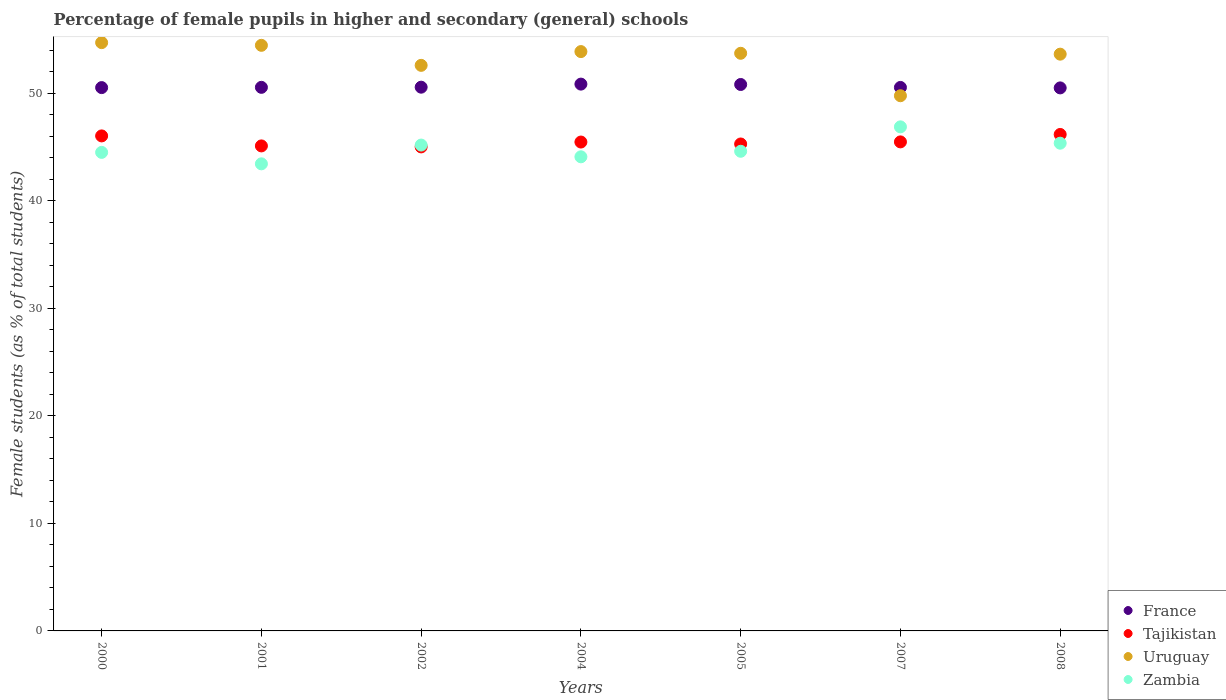How many different coloured dotlines are there?
Ensure brevity in your answer.  4. Is the number of dotlines equal to the number of legend labels?
Ensure brevity in your answer.  Yes. What is the percentage of female pupils in higher and secondary schools in France in 2000?
Your answer should be very brief. 50.54. Across all years, what is the maximum percentage of female pupils in higher and secondary schools in Zambia?
Make the answer very short. 46.89. Across all years, what is the minimum percentage of female pupils in higher and secondary schools in Zambia?
Ensure brevity in your answer.  43.45. In which year was the percentage of female pupils in higher and secondary schools in Zambia maximum?
Provide a short and direct response. 2007. In which year was the percentage of female pupils in higher and secondary schools in Zambia minimum?
Offer a very short reply. 2001. What is the total percentage of female pupils in higher and secondary schools in France in the graph?
Your response must be concise. 354.45. What is the difference between the percentage of female pupils in higher and secondary schools in Tajikistan in 2000 and that in 2007?
Ensure brevity in your answer.  0.56. What is the difference between the percentage of female pupils in higher and secondary schools in Uruguay in 2001 and the percentage of female pupils in higher and secondary schools in France in 2008?
Give a very brief answer. 3.96. What is the average percentage of female pupils in higher and secondary schools in France per year?
Keep it short and to the point. 50.64. In the year 2004, what is the difference between the percentage of female pupils in higher and secondary schools in France and percentage of female pupils in higher and secondary schools in Zambia?
Ensure brevity in your answer.  6.76. In how many years, is the percentage of female pupils in higher and secondary schools in France greater than 12 %?
Your answer should be very brief. 7. What is the ratio of the percentage of female pupils in higher and secondary schools in Tajikistan in 2001 to that in 2002?
Provide a succinct answer. 1. What is the difference between the highest and the second highest percentage of female pupils in higher and secondary schools in Tajikistan?
Make the answer very short. 0.13. What is the difference between the highest and the lowest percentage of female pupils in higher and secondary schools in Uruguay?
Your answer should be very brief. 4.94. Is the percentage of female pupils in higher and secondary schools in France strictly greater than the percentage of female pupils in higher and secondary schools in Uruguay over the years?
Your answer should be compact. No. How many dotlines are there?
Make the answer very short. 4. How many years are there in the graph?
Your answer should be compact. 7. Does the graph contain grids?
Provide a short and direct response. No. How many legend labels are there?
Offer a very short reply. 4. How are the legend labels stacked?
Provide a short and direct response. Vertical. What is the title of the graph?
Make the answer very short. Percentage of female pupils in higher and secondary (general) schools. What is the label or title of the X-axis?
Your answer should be compact. Years. What is the label or title of the Y-axis?
Your response must be concise. Female students (as % of total students). What is the Female students (as % of total students) of France in 2000?
Ensure brevity in your answer.  50.54. What is the Female students (as % of total students) of Tajikistan in 2000?
Give a very brief answer. 46.05. What is the Female students (as % of total students) of Uruguay in 2000?
Provide a succinct answer. 54.72. What is the Female students (as % of total students) of Zambia in 2000?
Your response must be concise. 44.52. What is the Female students (as % of total students) in France in 2001?
Ensure brevity in your answer.  50.57. What is the Female students (as % of total students) of Tajikistan in 2001?
Keep it short and to the point. 45.12. What is the Female students (as % of total students) of Uruguay in 2001?
Provide a succinct answer. 54.47. What is the Female students (as % of total students) of Zambia in 2001?
Your response must be concise. 43.45. What is the Female students (as % of total students) of France in 2002?
Provide a succinct answer. 50.58. What is the Female students (as % of total students) of Tajikistan in 2002?
Provide a short and direct response. 45.03. What is the Female students (as % of total students) in Uruguay in 2002?
Keep it short and to the point. 52.61. What is the Female students (as % of total students) in Zambia in 2002?
Provide a succinct answer. 45.19. What is the Female students (as % of total students) of France in 2004?
Provide a short and direct response. 50.87. What is the Female students (as % of total students) in Tajikistan in 2004?
Provide a short and direct response. 45.48. What is the Female students (as % of total students) in Uruguay in 2004?
Give a very brief answer. 53.89. What is the Female students (as % of total students) of Zambia in 2004?
Keep it short and to the point. 44.1. What is the Female students (as % of total students) in France in 2005?
Your response must be concise. 50.83. What is the Female students (as % of total students) of Tajikistan in 2005?
Make the answer very short. 45.3. What is the Female students (as % of total students) of Uruguay in 2005?
Offer a terse response. 53.73. What is the Female students (as % of total students) of Zambia in 2005?
Your answer should be compact. 44.62. What is the Female students (as % of total students) in France in 2007?
Keep it short and to the point. 50.56. What is the Female students (as % of total students) in Tajikistan in 2007?
Your response must be concise. 45.49. What is the Female students (as % of total students) in Uruguay in 2007?
Ensure brevity in your answer.  49.78. What is the Female students (as % of total students) in Zambia in 2007?
Your answer should be compact. 46.89. What is the Female students (as % of total students) in France in 2008?
Give a very brief answer. 50.51. What is the Female students (as % of total students) in Tajikistan in 2008?
Keep it short and to the point. 46.18. What is the Female students (as % of total students) in Uruguay in 2008?
Your answer should be compact. 53.65. What is the Female students (as % of total students) of Zambia in 2008?
Offer a terse response. 45.37. Across all years, what is the maximum Female students (as % of total students) in France?
Your response must be concise. 50.87. Across all years, what is the maximum Female students (as % of total students) of Tajikistan?
Provide a short and direct response. 46.18. Across all years, what is the maximum Female students (as % of total students) of Uruguay?
Make the answer very short. 54.72. Across all years, what is the maximum Female students (as % of total students) of Zambia?
Ensure brevity in your answer.  46.89. Across all years, what is the minimum Female students (as % of total students) of France?
Give a very brief answer. 50.51. Across all years, what is the minimum Female students (as % of total students) of Tajikistan?
Offer a terse response. 45.03. Across all years, what is the minimum Female students (as % of total students) in Uruguay?
Ensure brevity in your answer.  49.78. Across all years, what is the minimum Female students (as % of total students) of Zambia?
Offer a very short reply. 43.45. What is the total Female students (as % of total students) in France in the graph?
Ensure brevity in your answer.  354.45. What is the total Female students (as % of total students) of Tajikistan in the graph?
Give a very brief answer. 318.63. What is the total Female students (as % of total students) in Uruguay in the graph?
Ensure brevity in your answer.  372.87. What is the total Female students (as % of total students) in Zambia in the graph?
Your answer should be compact. 314.14. What is the difference between the Female students (as % of total students) of France in 2000 and that in 2001?
Provide a short and direct response. -0.02. What is the difference between the Female students (as % of total students) of Tajikistan in 2000 and that in 2001?
Keep it short and to the point. 0.93. What is the difference between the Female students (as % of total students) of Uruguay in 2000 and that in 2001?
Provide a short and direct response. 0.25. What is the difference between the Female students (as % of total students) of Zambia in 2000 and that in 2001?
Keep it short and to the point. 1.07. What is the difference between the Female students (as % of total students) in France in 2000 and that in 2002?
Make the answer very short. -0.04. What is the difference between the Female students (as % of total students) of Tajikistan in 2000 and that in 2002?
Your response must be concise. 1.02. What is the difference between the Female students (as % of total students) of Uruguay in 2000 and that in 2002?
Ensure brevity in your answer.  2.11. What is the difference between the Female students (as % of total students) of Zambia in 2000 and that in 2002?
Provide a short and direct response. -0.68. What is the difference between the Female students (as % of total students) of France in 2000 and that in 2004?
Provide a short and direct response. -0.32. What is the difference between the Female students (as % of total students) in Tajikistan in 2000 and that in 2004?
Your answer should be compact. 0.57. What is the difference between the Female students (as % of total students) in Uruguay in 2000 and that in 2004?
Provide a short and direct response. 0.83. What is the difference between the Female students (as % of total students) in Zambia in 2000 and that in 2004?
Your answer should be compact. 0.41. What is the difference between the Female students (as % of total students) of France in 2000 and that in 2005?
Your answer should be compact. -0.29. What is the difference between the Female students (as % of total students) of Tajikistan in 2000 and that in 2005?
Your response must be concise. 0.75. What is the difference between the Female students (as % of total students) in Uruguay in 2000 and that in 2005?
Make the answer very short. 0.99. What is the difference between the Female students (as % of total students) of Zambia in 2000 and that in 2005?
Offer a terse response. -0.1. What is the difference between the Female students (as % of total students) in France in 2000 and that in 2007?
Give a very brief answer. -0.02. What is the difference between the Female students (as % of total students) in Tajikistan in 2000 and that in 2007?
Your answer should be compact. 0.56. What is the difference between the Female students (as % of total students) in Uruguay in 2000 and that in 2007?
Your response must be concise. 4.94. What is the difference between the Female students (as % of total students) in Zambia in 2000 and that in 2007?
Offer a very short reply. -2.37. What is the difference between the Female students (as % of total students) of France in 2000 and that in 2008?
Your answer should be compact. 0.03. What is the difference between the Female students (as % of total students) in Tajikistan in 2000 and that in 2008?
Provide a short and direct response. -0.13. What is the difference between the Female students (as % of total students) in Uruguay in 2000 and that in 2008?
Provide a succinct answer. 1.07. What is the difference between the Female students (as % of total students) in Zambia in 2000 and that in 2008?
Ensure brevity in your answer.  -0.85. What is the difference between the Female students (as % of total students) of France in 2001 and that in 2002?
Make the answer very short. -0.01. What is the difference between the Female students (as % of total students) in Tajikistan in 2001 and that in 2002?
Your response must be concise. 0.09. What is the difference between the Female students (as % of total students) of Uruguay in 2001 and that in 2002?
Provide a short and direct response. 1.86. What is the difference between the Female students (as % of total students) of Zambia in 2001 and that in 2002?
Your response must be concise. -1.75. What is the difference between the Female students (as % of total students) in France in 2001 and that in 2004?
Ensure brevity in your answer.  -0.3. What is the difference between the Female students (as % of total students) of Tajikistan in 2001 and that in 2004?
Provide a succinct answer. -0.36. What is the difference between the Female students (as % of total students) in Uruguay in 2001 and that in 2004?
Offer a terse response. 0.58. What is the difference between the Female students (as % of total students) of Zambia in 2001 and that in 2004?
Provide a succinct answer. -0.65. What is the difference between the Female students (as % of total students) in France in 2001 and that in 2005?
Give a very brief answer. -0.27. What is the difference between the Female students (as % of total students) of Tajikistan in 2001 and that in 2005?
Offer a terse response. -0.18. What is the difference between the Female students (as % of total students) in Uruguay in 2001 and that in 2005?
Offer a very short reply. 0.74. What is the difference between the Female students (as % of total students) in Zambia in 2001 and that in 2005?
Provide a succinct answer. -1.17. What is the difference between the Female students (as % of total students) in France in 2001 and that in 2007?
Keep it short and to the point. 0.01. What is the difference between the Female students (as % of total students) in Tajikistan in 2001 and that in 2007?
Offer a terse response. -0.37. What is the difference between the Female students (as % of total students) of Uruguay in 2001 and that in 2007?
Provide a short and direct response. 4.69. What is the difference between the Female students (as % of total students) of Zambia in 2001 and that in 2007?
Offer a very short reply. -3.44. What is the difference between the Female students (as % of total students) of France in 2001 and that in 2008?
Your response must be concise. 0.05. What is the difference between the Female students (as % of total students) of Tajikistan in 2001 and that in 2008?
Provide a short and direct response. -1.06. What is the difference between the Female students (as % of total students) of Uruguay in 2001 and that in 2008?
Your response must be concise. 0.82. What is the difference between the Female students (as % of total students) in Zambia in 2001 and that in 2008?
Offer a terse response. -1.92. What is the difference between the Female students (as % of total students) in France in 2002 and that in 2004?
Your answer should be compact. -0.29. What is the difference between the Female students (as % of total students) in Tajikistan in 2002 and that in 2004?
Provide a short and direct response. -0.45. What is the difference between the Female students (as % of total students) in Uruguay in 2002 and that in 2004?
Provide a succinct answer. -1.28. What is the difference between the Female students (as % of total students) of Zambia in 2002 and that in 2004?
Provide a short and direct response. 1.09. What is the difference between the Female students (as % of total students) of France in 2002 and that in 2005?
Provide a short and direct response. -0.25. What is the difference between the Female students (as % of total students) of Tajikistan in 2002 and that in 2005?
Offer a very short reply. -0.27. What is the difference between the Female students (as % of total students) of Uruguay in 2002 and that in 2005?
Your answer should be very brief. -1.12. What is the difference between the Female students (as % of total students) in Zambia in 2002 and that in 2005?
Keep it short and to the point. 0.58. What is the difference between the Female students (as % of total students) of France in 2002 and that in 2007?
Your answer should be compact. 0.02. What is the difference between the Female students (as % of total students) in Tajikistan in 2002 and that in 2007?
Offer a very short reply. -0.47. What is the difference between the Female students (as % of total students) of Uruguay in 2002 and that in 2007?
Your answer should be compact. 2.83. What is the difference between the Female students (as % of total students) of Zambia in 2002 and that in 2007?
Make the answer very short. -1.69. What is the difference between the Female students (as % of total students) in France in 2002 and that in 2008?
Your answer should be very brief. 0.07. What is the difference between the Female students (as % of total students) in Tajikistan in 2002 and that in 2008?
Offer a very short reply. -1.16. What is the difference between the Female students (as % of total students) in Uruguay in 2002 and that in 2008?
Your answer should be very brief. -1.04. What is the difference between the Female students (as % of total students) of Zambia in 2002 and that in 2008?
Your answer should be compact. -0.17. What is the difference between the Female students (as % of total students) of France in 2004 and that in 2005?
Offer a terse response. 0.04. What is the difference between the Female students (as % of total students) in Tajikistan in 2004 and that in 2005?
Your answer should be very brief. 0.18. What is the difference between the Female students (as % of total students) of Uruguay in 2004 and that in 2005?
Provide a succinct answer. 0.16. What is the difference between the Female students (as % of total students) of Zambia in 2004 and that in 2005?
Your answer should be compact. -0.51. What is the difference between the Female students (as % of total students) in France in 2004 and that in 2007?
Offer a terse response. 0.31. What is the difference between the Female students (as % of total students) of Tajikistan in 2004 and that in 2007?
Give a very brief answer. -0.01. What is the difference between the Female students (as % of total students) in Uruguay in 2004 and that in 2007?
Give a very brief answer. 4.11. What is the difference between the Female students (as % of total students) of Zambia in 2004 and that in 2007?
Give a very brief answer. -2.79. What is the difference between the Female students (as % of total students) in France in 2004 and that in 2008?
Provide a succinct answer. 0.35. What is the difference between the Female students (as % of total students) of Tajikistan in 2004 and that in 2008?
Your answer should be compact. -0.7. What is the difference between the Female students (as % of total students) in Uruguay in 2004 and that in 2008?
Provide a short and direct response. 0.24. What is the difference between the Female students (as % of total students) of Zambia in 2004 and that in 2008?
Offer a very short reply. -1.27. What is the difference between the Female students (as % of total students) in France in 2005 and that in 2007?
Provide a succinct answer. 0.27. What is the difference between the Female students (as % of total students) of Tajikistan in 2005 and that in 2007?
Ensure brevity in your answer.  -0.19. What is the difference between the Female students (as % of total students) of Uruguay in 2005 and that in 2007?
Offer a terse response. 3.95. What is the difference between the Female students (as % of total students) in Zambia in 2005 and that in 2007?
Your response must be concise. -2.27. What is the difference between the Female students (as % of total students) of France in 2005 and that in 2008?
Make the answer very short. 0.32. What is the difference between the Female students (as % of total students) of Tajikistan in 2005 and that in 2008?
Ensure brevity in your answer.  -0.89. What is the difference between the Female students (as % of total students) of Uruguay in 2005 and that in 2008?
Ensure brevity in your answer.  0.08. What is the difference between the Female students (as % of total students) in Zambia in 2005 and that in 2008?
Offer a terse response. -0.75. What is the difference between the Female students (as % of total students) in France in 2007 and that in 2008?
Your answer should be compact. 0.04. What is the difference between the Female students (as % of total students) in Tajikistan in 2007 and that in 2008?
Your response must be concise. -0.69. What is the difference between the Female students (as % of total students) in Uruguay in 2007 and that in 2008?
Keep it short and to the point. -3.87. What is the difference between the Female students (as % of total students) of Zambia in 2007 and that in 2008?
Give a very brief answer. 1.52. What is the difference between the Female students (as % of total students) in France in 2000 and the Female students (as % of total students) in Tajikistan in 2001?
Offer a very short reply. 5.42. What is the difference between the Female students (as % of total students) of France in 2000 and the Female students (as % of total students) of Uruguay in 2001?
Your answer should be compact. -3.93. What is the difference between the Female students (as % of total students) in France in 2000 and the Female students (as % of total students) in Zambia in 2001?
Give a very brief answer. 7.09. What is the difference between the Female students (as % of total students) of Tajikistan in 2000 and the Female students (as % of total students) of Uruguay in 2001?
Give a very brief answer. -8.43. What is the difference between the Female students (as % of total students) of Tajikistan in 2000 and the Female students (as % of total students) of Zambia in 2001?
Keep it short and to the point. 2.6. What is the difference between the Female students (as % of total students) in Uruguay in 2000 and the Female students (as % of total students) in Zambia in 2001?
Provide a succinct answer. 11.27. What is the difference between the Female students (as % of total students) in France in 2000 and the Female students (as % of total students) in Tajikistan in 2002?
Your answer should be very brief. 5.52. What is the difference between the Female students (as % of total students) in France in 2000 and the Female students (as % of total students) in Uruguay in 2002?
Provide a short and direct response. -2.07. What is the difference between the Female students (as % of total students) in France in 2000 and the Female students (as % of total students) in Zambia in 2002?
Provide a short and direct response. 5.35. What is the difference between the Female students (as % of total students) of Tajikistan in 2000 and the Female students (as % of total students) of Uruguay in 2002?
Offer a very short reply. -6.56. What is the difference between the Female students (as % of total students) of Tajikistan in 2000 and the Female students (as % of total students) of Zambia in 2002?
Ensure brevity in your answer.  0.85. What is the difference between the Female students (as % of total students) in Uruguay in 2000 and the Female students (as % of total students) in Zambia in 2002?
Ensure brevity in your answer.  9.53. What is the difference between the Female students (as % of total students) of France in 2000 and the Female students (as % of total students) of Tajikistan in 2004?
Your response must be concise. 5.06. What is the difference between the Female students (as % of total students) of France in 2000 and the Female students (as % of total students) of Uruguay in 2004?
Provide a short and direct response. -3.35. What is the difference between the Female students (as % of total students) of France in 2000 and the Female students (as % of total students) of Zambia in 2004?
Offer a very short reply. 6.44. What is the difference between the Female students (as % of total students) in Tajikistan in 2000 and the Female students (as % of total students) in Uruguay in 2004?
Provide a succinct answer. -7.84. What is the difference between the Female students (as % of total students) in Tajikistan in 2000 and the Female students (as % of total students) in Zambia in 2004?
Provide a short and direct response. 1.94. What is the difference between the Female students (as % of total students) in Uruguay in 2000 and the Female students (as % of total students) in Zambia in 2004?
Your response must be concise. 10.62. What is the difference between the Female students (as % of total students) of France in 2000 and the Female students (as % of total students) of Tajikistan in 2005?
Make the answer very short. 5.24. What is the difference between the Female students (as % of total students) in France in 2000 and the Female students (as % of total students) in Uruguay in 2005?
Ensure brevity in your answer.  -3.19. What is the difference between the Female students (as % of total students) of France in 2000 and the Female students (as % of total students) of Zambia in 2005?
Keep it short and to the point. 5.92. What is the difference between the Female students (as % of total students) in Tajikistan in 2000 and the Female students (as % of total students) in Uruguay in 2005?
Offer a terse response. -7.69. What is the difference between the Female students (as % of total students) of Tajikistan in 2000 and the Female students (as % of total students) of Zambia in 2005?
Keep it short and to the point. 1.43. What is the difference between the Female students (as % of total students) in Uruguay in 2000 and the Female students (as % of total students) in Zambia in 2005?
Ensure brevity in your answer.  10.11. What is the difference between the Female students (as % of total students) of France in 2000 and the Female students (as % of total students) of Tajikistan in 2007?
Offer a terse response. 5.05. What is the difference between the Female students (as % of total students) of France in 2000 and the Female students (as % of total students) of Uruguay in 2007?
Your answer should be very brief. 0.76. What is the difference between the Female students (as % of total students) of France in 2000 and the Female students (as % of total students) of Zambia in 2007?
Make the answer very short. 3.65. What is the difference between the Female students (as % of total students) of Tajikistan in 2000 and the Female students (as % of total students) of Uruguay in 2007?
Your response must be concise. -3.74. What is the difference between the Female students (as % of total students) of Tajikistan in 2000 and the Female students (as % of total students) of Zambia in 2007?
Keep it short and to the point. -0.84. What is the difference between the Female students (as % of total students) of Uruguay in 2000 and the Female students (as % of total students) of Zambia in 2007?
Provide a short and direct response. 7.83. What is the difference between the Female students (as % of total students) of France in 2000 and the Female students (as % of total students) of Tajikistan in 2008?
Provide a short and direct response. 4.36. What is the difference between the Female students (as % of total students) in France in 2000 and the Female students (as % of total students) in Uruguay in 2008?
Ensure brevity in your answer.  -3.11. What is the difference between the Female students (as % of total students) in France in 2000 and the Female students (as % of total students) in Zambia in 2008?
Your response must be concise. 5.17. What is the difference between the Female students (as % of total students) of Tajikistan in 2000 and the Female students (as % of total students) of Uruguay in 2008?
Your answer should be very brief. -7.6. What is the difference between the Female students (as % of total students) in Tajikistan in 2000 and the Female students (as % of total students) in Zambia in 2008?
Offer a very short reply. 0.68. What is the difference between the Female students (as % of total students) of Uruguay in 2000 and the Female students (as % of total students) of Zambia in 2008?
Ensure brevity in your answer.  9.35. What is the difference between the Female students (as % of total students) in France in 2001 and the Female students (as % of total students) in Tajikistan in 2002?
Provide a succinct answer. 5.54. What is the difference between the Female students (as % of total students) in France in 2001 and the Female students (as % of total students) in Uruguay in 2002?
Ensure brevity in your answer.  -2.05. What is the difference between the Female students (as % of total students) of France in 2001 and the Female students (as % of total students) of Zambia in 2002?
Your response must be concise. 5.37. What is the difference between the Female students (as % of total students) in Tajikistan in 2001 and the Female students (as % of total students) in Uruguay in 2002?
Make the answer very short. -7.49. What is the difference between the Female students (as % of total students) in Tajikistan in 2001 and the Female students (as % of total students) in Zambia in 2002?
Your answer should be compact. -0.08. What is the difference between the Female students (as % of total students) in Uruguay in 2001 and the Female students (as % of total students) in Zambia in 2002?
Ensure brevity in your answer.  9.28. What is the difference between the Female students (as % of total students) of France in 2001 and the Female students (as % of total students) of Tajikistan in 2004?
Provide a short and direct response. 5.09. What is the difference between the Female students (as % of total students) in France in 2001 and the Female students (as % of total students) in Uruguay in 2004?
Provide a succinct answer. -3.33. What is the difference between the Female students (as % of total students) of France in 2001 and the Female students (as % of total students) of Zambia in 2004?
Make the answer very short. 6.46. What is the difference between the Female students (as % of total students) of Tajikistan in 2001 and the Female students (as % of total students) of Uruguay in 2004?
Provide a succinct answer. -8.77. What is the difference between the Female students (as % of total students) of Tajikistan in 2001 and the Female students (as % of total students) of Zambia in 2004?
Offer a terse response. 1.01. What is the difference between the Female students (as % of total students) in Uruguay in 2001 and the Female students (as % of total students) in Zambia in 2004?
Your answer should be very brief. 10.37. What is the difference between the Female students (as % of total students) in France in 2001 and the Female students (as % of total students) in Tajikistan in 2005?
Keep it short and to the point. 5.27. What is the difference between the Female students (as % of total students) of France in 2001 and the Female students (as % of total students) of Uruguay in 2005?
Provide a succinct answer. -3.17. What is the difference between the Female students (as % of total students) of France in 2001 and the Female students (as % of total students) of Zambia in 2005?
Provide a short and direct response. 5.95. What is the difference between the Female students (as % of total students) in Tajikistan in 2001 and the Female students (as % of total students) in Uruguay in 2005?
Ensure brevity in your answer.  -8.62. What is the difference between the Female students (as % of total students) of Tajikistan in 2001 and the Female students (as % of total students) of Zambia in 2005?
Provide a succinct answer. 0.5. What is the difference between the Female students (as % of total students) of Uruguay in 2001 and the Female students (as % of total students) of Zambia in 2005?
Your answer should be very brief. 9.86. What is the difference between the Female students (as % of total students) in France in 2001 and the Female students (as % of total students) in Tajikistan in 2007?
Make the answer very short. 5.07. What is the difference between the Female students (as % of total students) in France in 2001 and the Female students (as % of total students) in Uruguay in 2007?
Offer a terse response. 0.78. What is the difference between the Female students (as % of total students) in France in 2001 and the Female students (as % of total students) in Zambia in 2007?
Your response must be concise. 3.68. What is the difference between the Female students (as % of total students) in Tajikistan in 2001 and the Female students (as % of total students) in Uruguay in 2007?
Keep it short and to the point. -4.67. What is the difference between the Female students (as % of total students) of Tajikistan in 2001 and the Female students (as % of total students) of Zambia in 2007?
Your answer should be compact. -1.77. What is the difference between the Female students (as % of total students) of Uruguay in 2001 and the Female students (as % of total students) of Zambia in 2007?
Your response must be concise. 7.58. What is the difference between the Female students (as % of total students) in France in 2001 and the Female students (as % of total students) in Tajikistan in 2008?
Your response must be concise. 4.38. What is the difference between the Female students (as % of total students) in France in 2001 and the Female students (as % of total students) in Uruguay in 2008?
Offer a very short reply. -3.09. What is the difference between the Female students (as % of total students) in France in 2001 and the Female students (as % of total students) in Zambia in 2008?
Provide a short and direct response. 5.2. What is the difference between the Female students (as % of total students) in Tajikistan in 2001 and the Female students (as % of total students) in Uruguay in 2008?
Offer a very short reply. -8.53. What is the difference between the Female students (as % of total students) in Tajikistan in 2001 and the Female students (as % of total students) in Zambia in 2008?
Keep it short and to the point. -0.25. What is the difference between the Female students (as % of total students) of Uruguay in 2001 and the Female students (as % of total students) of Zambia in 2008?
Offer a very short reply. 9.1. What is the difference between the Female students (as % of total students) in France in 2002 and the Female students (as % of total students) in Tajikistan in 2004?
Keep it short and to the point. 5.1. What is the difference between the Female students (as % of total students) in France in 2002 and the Female students (as % of total students) in Uruguay in 2004?
Make the answer very short. -3.31. What is the difference between the Female students (as % of total students) of France in 2002 and the Female students (as % of total students) of Zambia in 2004?
Ensure brevity in your answer.  6.48. What is the difference between the Female students (as % of total students) in Tajikistan in 2002 and the Female students (as % of total students) in Uruguay in 2004?
Give a very brief answer. -8.87. What is the difference between the Female students (as % of total students) in Tajikistan in 2002 and the Female students (as % of total students) in Zambia in 2004?
Provide a short and direct response. 0.92. What is the difference between the Female students (as % of total students) of Uruguay in 2002 and the Female students (as % of total students) of Zambia in 2004?
Your answer should be very brief. 8.51. What is the difference between the Female students (as % of total students) of France in 2002 and the Female students (as % of total students) of Tajikistan in 2005?
Your response must be concise. 5.28. What is the difference between the Female students (as % of total students) of France in 2002 and the Female students (as % of total students) of Uruguay in 2005?
Offer a very short reply. -3.15. What is the difference between the Female students (as % of total students) in France in 2002 and the Female students (as % of total students) in Zambia in 2005?
Your response must be concise. 5.96. What is the difference between the Female students (as % of total students) of Tajikistan in 2002 and the Female students (as % of total students) of Uruguay in 2005?
Your answer should be compact. -8.71. What is the difference between the Female students (as % of total students) of Tajikistan in 2002 and the Female students (as % of total students) of Zambia in 2005?
Give a very brief answer. 0.41. What is the difference between the Female students (as % of total students) in Uruguay in 2002 and the Female students (as % of total students) in Zambia in 2005?
Make the answer very short. 7.99. What is the difference between the Female students (as % of total students) in France in 2002 and the Female students (as % of total students) in Tajikistan in 2007?
Keep it short and to the point. 5.09. What is the difference between the Female students (as % of total students) in France in 2002 and the Female students (as % of total students) in Uruguay in 2007?
Make the answer very short. 0.8. What is the difference between the Female students (as % of total students) of France in 2002 and the Female students (as % of total students) of Zambia in 2007?
Make the answer very short. 3.69. What is the difference between the Female students (as % of total students) of Tajikistan in 2002 and the Female students (as % of total students) of Uruguay in 2007?
Your response must be concise. -4.76. What is the difference between the Female students (as % of total students) of Tajikistan in 2002 and the Female students (as % of total students) of Zambia in 2007?
Provide a short and direct response. -1.86. What is the difference between the Female students (as % of total students) in Uruguay in 2002 and the Female students (as % of total students) in Zambia in 2007?
Offer a terse response. 5.72. What is the difference between the Female students (as % of total students) in France in 2002 and the Female students (as % of total students) in Tajikistan in 2008?
Offer a terse response. 4.4. What is the difference between the Female students (as % of total students) in France in 2002 and the Female students (as % of total students) in Uruguay in 2008?
Ensure brevity in your answer.  -3.07. What is the difference between the Female students (as % of total students) of France in 2002 and the Female students (as % of total students) of Zambia in 2008?
Provide a succinct answer. 5.21. What is the difference between the Female students (as % of total students) in Tajikistan in 2002 and the Female students (as % of total students) in Uruguay in 2008?
Your response must be concise. -8.63. What is the difference between the Female students (as % of total students) in Tajikistan in 2002 and the Female students (as % of total students) in Zambia in 2008?
Your answer should be compact. -0.34. What is the difference between the Female students (as % of total students) in Uruguay in 2002 and the Female students (as % of total students) in Zambia in 2008?
Ensure brevity in your answer.  7.24. What is the difference between the Female students (as % of total students) of France in 2004 and the Female students (as % of total students) of Tajikistan in 2005?
Your answer should be compact. 5.57. What is the difference between the Female students (as % of total students) of France in 2004 and the Female students (as % of total students) of Uruguay in 2005?
Your answer should be very brief. -2.87. What is the difference between the Female students (as % of total students) of France in 2004 and the Female students (as % of total students) of Zambia in 2005?
Provide a succinct answer. 6.25. What is the difference between the Female students (as % of total students) of Tajikistan in 2004 and the Female students (as % of total students) of Uruguay in 2005?
Ensure brevity in your answer.  -8.26. What is the difference between the Female students (as % of total students) in Tajikistan in 2004 and the Female students (as % of total students) in Zambia in 2005?
Provide a short and direct response. 0.86. What is the difference between the Female students (as % of total students) in Uruguay in 2004 and the Female students (as % of total students) in Zambia in 2005?
Give a very brief answer. 9.27. What is the difference between the Female students (as % of total students) of France in 2004 and the Female students (as % of total students) of Tajikistan in 2007?
Offer a terse response. 5.37. What is the difference between the Female students (as % of total students) in France in 2004 and the Female students (as % of total students) in Uruguay in 2007?
Your response must be concise. 1.08. What is the difference between the Female students (as % of total students) of France in 2004 and the Female students (as % of total students) of Zambia in 2007?
Your answer should be compact. 3.98. What is the difference between the Female students (as % of total students) in Tajikistan in 2004 and the Female students (as % of total students) in Uruguay in 2007?
Your answer should be very brief. -4.31. What is the difference between the Female students (as % of total students) of Tajikistan in 2004 and the Female students (as % of total students) of Zambia in 2007?
Offer a terse response. -1.41. What is the difference between the Female students (as % of total students) in Uruguay in 2004 and the Female students (as % of total students) in Zambia in 2007?
Ensure brevity in your answer.  7. What is the difference between the Female students (as % of total students) in France in 2004 and the Female students (as % of total students) in Tajikistan in 2008?
Your answer should be compact. 4.68. What is the difference between the Female students (as % of total students) in France in 2004 and the Female students (as % of total students) in Uruguay in 2008?
Your answer should be compact. -2.79. What is the difference between the Female students (as % of total students) of France in 2004 and the Female students (as % of total students) of Zambia in 2008?
Ensure brevity in your answer.  5.5. What is the difference between the Female students (as % of total students) in Tajikistan in 2004 and the Female students (as % of total students) in Uruguay in 2008?
Provide a succinct answer. -8.17. What is the difference between the Female students (as % of total students) of Tajikistan in 2004 and the Female students (as % of total students) of Zambia in 2008?
Give a very brief answer. 0.11. What is the difference between the Female students (as % of total students) in Uruguay in 2004 and the Female students (as % of total students) in Zambia in 2008?
Ensure brevity in your answer.  8.52. What is the difference between the Female students (as % of total students) of France in 2005 and the Female students (as % of total students) of Tajikistan in 2007?
Keep it short and to the point. 5.34. What is the difference between the Female students (as % of total students) in France in 2005 and the Female students (as % of total students) in Uruguay in 2007?
Your response must be concise. 1.05. What is the difference between the Female students (as % of total students) in France in 2005 and the Female students (as % of total students) in Zambia in 2007?
Offer a very short reply. 3.94. What is the difference between the Female students (as % of total students) in Tajikistan in 2005 and the Female students (as % of total students) in Uruguay in 2007?
Your answer should be very brief. -4.49. What is the difference between the Female students (as % of total students) of Tajikistan in 2005 and the Female students (as % of total students) of Zambia in 2007?
Provide a succinct answer. -1.59. What is the difference between the Female students (as % of total students) of Uruguay in 2005 and the Female students (as % of total students) of Zambia in 2007?
Your response must be concise. 6.84. What is the difference between the Female students (as % of total students) of France in 2005 and the Female students (as % of total students) of Tajikistan in 2008?
Provide a short and direct response. 4.65. What is the difference between the Female students (as % of total students) of France in 2005 and the Female students (as % of total students) of Uruguay in 2008?
Give a very brief answer. -2.82. What is the difference between the Female students (as % of total students) of France in 2005 and the Female students (as % of total students) of Zambia in 2008?
Give a very brief answer. 5.46. What is the difference between the Female students (as % of total students) in Tajikistan in 2005 and the Female students (as % of total students) in Uruguay in 2008?
Provide a short and direct response. -8.36. What is the difference between the Female students (as % of total students) in Tajikistan in 2005 and the Female students (as % of total students) in Zambia in 2008?
Provide a succinct answer. -0.07. What is the difference between the Female students (as % of total students) in Uruguay in 2005 and the Female students (as % of total students) in Zambia in 2008?
Your answer should be very brief. 8.36. What is the difference between the Female students (as % of total students) in France in 2007 and the Female students (as % of total students) in Tajikistan in 2008?
Keep it short and to the point. 4.38. What is the difference between the Female students (as % of total students) of France in 2007 and the Female students (as % of total students) of Uruguay in 2008?
Your answer should be compact. -3.09. What is the difference between the Female students (as % of total students) in France in 2007 and the Female students (as % of total students) in Zambia in 2008?
Ensure brevity in your answer.  5.19. What is the difference between the Female students (as % of total students) of Tajikistan in 2007 and the Female students (as % of total students) of Uruguay in 2008?
Offer a very short reply. -8.16. What is the difference between the Female students (as % of total students) of Tajikistan in 2007 and the Female students (as % of total students) of Zambia in 2008?
Your answer should be very brief. 0.12. What is the difference between the Female students (as % of total students) in Uruguay in 2007 and the Female students (as % of total students) in Zambia in 2008?
Keep it short and to the point. 4.41. What is the average Female students (as % of total students) of France per year?
Your answer should be very brief. 50.64. What is the average Female students (as % of total students) of Tajikistan per year?
Offer a terse response. 45.52. What is the average Female students (as % of total students) of Uruguay per year?
Keep it short and to the point. 53.27. What is the average Female students (as % of total students) in Zambia per year?
Your answer should be compact. 44.88. In the year 2000, what is the difference between the Female students (as % of total students) of France and Female students (as % of total students) of Tajikistan?
Keep it short and to the point. 4.49. In the year 2000, what is the difference between the Female students (as % of total students) in France and Female students (as % of total students) in Uruguay?
Your response must be concise. -4.18. In the year 2000, what is the difference between the Female students (as % of total students) of France and Female students (as % of total students) of Zambia?
Provide a succinct answer. 6.03. In the year 2000, what is the difference between the Female students (as % of total students) of Tajikistan and Female students (as % of total students) of Uruguay?
Offer a terse response. -8.68. In the year 2000, what is the difference between the Female students (as % of total students) in Tajikistan and Female students (as % of total students) in Zambia?
Your answer should be compact. 1.53. In the year 2000, what is the difference between the Female students (as % of total students) in Uruguay and Female students (as % of total students) in Zambia?
Offer a very short reply. 10.21. In the year 2001, what is the difference between the Female students (as % of total students) in France and Female students (as % of total students) in Tajikistan?
Provide a short and direct response. 5.45. In the year 2001, what is the difference between the Female students (as % of total students) in France and Female students (as % of total students) in Uruguay?
Your answer should be compact. -3.91. In the year 2001, what is the difference between the Female students (as % of total students) of France and Female students (as % of total students) of Zambia?
Make the answer very short. 7.12. In the year 2001, what is the difference between the Female students (as % of total students) of Tajikistan and Female students (as % of total students) of Uruguay?
Provide a short and direct response. -9.36. In the year 2001, what is the difference between the Female students (as % of total students) in Tajikistan and Female students (as % of total students) in Zambia?
Give a very brief answer. 1.67. In the year 2001, what is the difference between the Female students (as % of total students) of Uruguay and Female students (as % of total students) of Zambia?
Your answer should be compact. 11.02. In the year 2002, what is the difference between the Female students (as % of total students) of France and Female students (as % of total students) of Tajikistan?
Offer a very short reply. 5.55. In the year 2002, what is the difference between the Female students (as % of total students) in France and Female students (as % of total students) in Uruguay?
Ensure brevity in your answer.  -2.03. In the year 2002, what is the difference between the Female students (as % of total students) of France and Female students (as % of total students) of Zambia?
Keep it short and to the point. 5.38. In the year 2002, what is the difference between the Female students (as % of total students) in Tajikistan and Female students (as % of total students) in Uruguay?
Make the answer very short. -7.59. In the year 2002, what is the difference between the Female students (as % of total students) in Tajikistan and Female students (as % of total students) in Zambia?
Ensure brevity in your answer.  -0.17. In the year 2002, what is the difference between the Female students (as % of total students) in Uruguay and Female students (as % of total students) in Zambia?
Offer a very short reply. 7.42. In the year 2004, what is the difference between the Female students (as % of total students) of France and Female students (as % of total students) of Tajikistan?
Offer a terse response. 5.39. In the year 2004, what is the difference between the Female students (as % of total students) in France and Female students (as % of total students) in Uruguay?
Provide a succinct answer. -3.03. In the year 2004, what is the difference between the Female students (as % of total students) of France and Female students (as % of total students) of Zambia?
Your answer should be compact. 6.76. In the year 2004, what is the difference between the Female students (as % of total students) in Tajikistan and Female students (as % of total students) in Uruguay?
Provide a succinct answer. -8.41. In the year 2004, what is the difference between the Female students (as % of total students) of Tajikistan and Female students (as % of total students) of Zambia?
Provide a succinct answer. 1.37. In the year 2004, what is the difference between the Female students (as % of total students) of Uruguay and Female students (as % of total students) of Zambia?
Offer a terse response. 9.79. In the year 2005, what is the difference between the Female students (as % of total students) of France and Female students (as % of total students) of Tajikistan?
Your answer should be compact. 5.53. In the year 2005, what is the difference between the Female students (as % of total students) of France and Female students (as % of total students) of Uruguay?
Give a very brief answer. -2.9. In the year 2005, what is the difference between the Female students (as % of total students) of France and Female students (as % of total students) of Zambia?
Offer a terse response. 6.21. In the year 2005, what is the difference between the Female students (as % of total students) in Tajikistan and Female students (as % of total students) in Uruguay?
Offer a terse response. -8.44. In the year 2005, what is the difference between the Female students (as % of total students) in Tajikistan and Female students (as % of total students) in Zambia?
Provide a succinct answer. 0.68. In the year 2005, what is the difference between the Female students (as % of total students) in Uruguay and Female students (as % of total students) in Zambia?
Offer a very short reply. 9.12. In the year 2007, what is the difference between the Female students (as % of total students) in France and Female students (as % of total students) in Tajikistan?
Provide a succinct answer. 5.07. In the year 2007, what is the difference between the Female students (as % of total students) of France and Female students (as % of total students) of Uruguay?
Provide a succinct answer. 0.77. In the year 2007, what is the difference between the Female students (as % of total students) of France and Female students (as % of total students) of Zambia?
Your answer should be very brief. 3.67. In the year 2007, what is the difference between the Female students (as % of total students) in Tajikistan and Female students (as % of total students) in Uruguay?
Provide a succinct answer. -4.29. In the year 2007, what is the difference between the Female students (as % of total students) of Tajikistan and Female students (as % of total students) of Zambia?
Your answer should be very brief. -1.4. In the year 2007, what is the difference between the Female students (as % of total students) in Uruguay and Female students (as % of total students) in Zambia?
Make the answer very short. 2.9. In the year 2008, what is the difference between the Female students (as % of total students) of France and Female students (as % of total students) of Tajikistan?
Your answer should be very brief. 4.33. In the year 2008, what is the difference between the Female students (as % of total students) in France and Female students (as % of total students) in Uruguay?
Offer a very short reply. -3.14. In the year 2008, what is the difference between the Female students (as % of total students) in France and Female students (as % of total students) in Zambia?
Provide a succinct answer. 5.14. In the year 2008, what is the difference between the Female students (as % of total students) of Tajikistan and Female students (as % of total students) of Uruguay?
Ensure brevity in your answer.  -7.47. In the year 2008, what is the difference between the Female students (as % of total students) in Tajikistan and Female students (as % of total students) in Zambia?
Your answer should be compact. 0.81. In the year 2008, what is the difference between the Female students (as % of total students) of Uruguay and Female students (as % of total students) of Zambia?
Your answer should be compact. 8.28. What is the ratio of the Female students (as % of total students) in Tajikistan in 2000 to that in 2001?
Provide a succinct answer. 1.02. What is the ratio of the Female students (as % of total students) of Zambia in 2000 to that in 2001?
Your answer should be compact. 1.02. What is the ratio of the Female students (as % of total students) of Tajikistan in 2000 to that in 2002?
Your answer should be compact. 1.02. What is the ratio of the Female students (as % of total students) of Uruguay in 2000 to that in 2002?
Offer a terse response. 1.04. What is the ratio of the Female students (as % of total students) in Zambia in 2000 to that in 2002?
Ensure brevity in your answer.  0.98. What is the ratio of the Female students (as % of total students) in France in 2000 to that in 2004?
Provide a succinct answer. 0.99. What is the ratio of the Female students (as % of total students) in Tajikistan in 2000 to that in 2004?
Keep it short and to the point. 1.01. What is the ratio of the Female students (as % of total students) in Uruguay in 2000 to that in 2004?
Offer a very short reply. 1.02. What is the ratio of the Female students (as % of total students) in Zambia in 2000 to that in 2004?
Make the answer very short. 1.01. What is the ratio of the Female students (as % of total students) in France in 2000 to that in 2005?
Provide a succinct answer. 0.99. What is the ratio of the Female students (as % of total students) in Tajikistan in 2000 to that in 2005?
Offer a very short reply. 1.02. What is the ratio of the Female students (as % of total students) of Uruguay in 2000 to that in 2005?
Make the answer very short. 1.02. What is the ratio of the Female students (as % of total students) of Zambia in 2000 to that in 2005?
Keep it short and to the point. 1. What is the ratio of the Female students (as % of total students) of Tajikistan in 2000 to that in 2007?
Provide a succinct answer. 1.01. What is the ratio of the Female students (as % of total students) of Uruguay in 2000 to that in 2007?
Offer a terse response. 1.1. What is the ratio of the Female students (as % of total students) in Zambia in 2000 to that in 2007?
Give a very brief answer. 0.95. What is the ratio of the Female students (as % of total students) in France in 2000 to that in 2008?
Your answer should be compact. 1. What is the ratio of the Female students (as % of total students) in Tajikistan in 2000 to that in 2008?
Offer a terse response. 1. What is the ratio of the Female students (as % of total students) of Uruguay in 2000 to that in 2008?
Give a very brief answer. 1.02. What is the ratio of the Female students (as % of total students) of Zambia in 2000 to that in 2008?
Offer a terse response. 0.98. What is the ratio of the Female students (as % of total students) of Uruguay in 2001 to that in 2002?
Ensure brevity in your answer.  1.04. What is the ratio of the Female students (as % of total students) of Zambia in 2001 to that in 2002?
Make the answer very short. 0.96. What is the ratio of the Female students (as % of total students) of Uruguay in 2001 to that in 2004?
Provide a short and direct response. 1.01. What is the ratio of the Female students (as % of total students) in Zambia in 2001 to that in 2004?
Offer a terse response. 0.99. What is the ratio of the Female students (as % of total students) of France in 2001 to that in 2005?
Offer a very short reply. 0.99. What is the ratio of the Female students (as % of total students) in Tajikistan in 2001 to that in 2005?
Offer a terse response. 1. What is the ratio of the Female students (as % of total students) of Uruguay in 2001 to that in 2005?
Provide a short and direct response. 1.01. What is the ratio of the Female students (as % of total students) of Zambia in 2001 to that in 2005?
Your response must be concise. 0.97. What is the ratio of the Female students (as % of total students) of Tajikistan in 2001 to that in 2007?
Offer a terse response. 0.99. What is the ratio of the Female students (as % of total students) in Uruguay in 2001 to that in 2007?
Your answer should be very brief. 1.09. What is the ratio of the Female students (as % of total students) in Zambia in 2001 to that in 2007?
Your answer should be very brief. 0.93. What is the ratio of the Female students (as % of total students) in France in 2001 to that in 2008?
Ensure brevity in your answer.  1. What is the ratio of the Female students (as % of total students) of Tajikistan in 2001 to that in 2008?
Offer a very short reply. 0.98. What is the ratio of the Female students (as % of total students) of Uruguay in 2001 to that in 2008?
Your answer should be compact. 1.02. What is the ratio of the Female students (as % of total students) in Zambia in 2001 to that in 2008?
Ensure brevity in your answer.  0.96. What is the ratio of the Female students (as % of total students) of Uruguay in 2002 to that in 2004?
Your answer should be compact. 0.98. What is the ratio of the Female students (as % of total students) of Zambia in 2002 to that in 2004?
Make the answer very short. 1.02. What is the ratio of the Female students (as % of total students) in Uruguay in 2002 to that in 2005?
Ensure brevity in your answer.  0.98. What is the ratio of the Female students (as % of total students) in Zambia in 2002 to that in 2005?
Ensure brevity in your answer.  1.01. What is the ratio of the Female students (as % of total students) of Tajikistan in 2002 to that in 2007?
Offer a very short reply. 0.99. What is the ratio of the Female students (as % of total students) in Uruguay in 2002 to that in 2007?
Provide a short and direct response. 1.06. What is the ratio of the Female students (as % of total students) of Zambia in 2002 to that in 2007?
Your answer should be very brief. 0.96. What is the ratio of the Female students (as % of total students) in France in 2002 to that in 2008?
Your response must be concise. 1. What is the ratio of the Female students (as % of total students) in Uruguay in 2002 to that in 2008?
Ensure brevity in your answer.  0.98. What is the ratio of the Female students (as % of total students) of Uruguay in 2004 to that in 2007?
Your answer should be very brief. 1.08. What is the ratio of the Female students (as % of total students) of Zambia in 2004 to that in 2007?
Offer a terse response. 0.94. What is the ratio of the Female students (as % of total students) of Tajikistan in 2004 to that in 2008?
Offer a terse response. 0.98. What is the ratio of the Female students (as % of total students) of Uruguay in 2004 to that in 2008?
Give a very brief answer. 1. What is the ratio of the Female students (as % of total students) of Zambia in 2004 to that in 2008?
Your response must be concise. 0.97. What is the ratio of the Female students (as % of total students) of France in 2005 to that in 2007?
Offer a terse response. 1.01. What is the ratio of the Female students (as % of total students) in Tajikistan in 2005 to that in 2007?
Your response must be concise. 1. What is the ratio of the Female students (as % of total students) in Uruguay in 2005 to that in 2007?
Provide a succinct answer. 1.08. What is the ratio of the Female students (as % of total students) of Zambia in 2005 to that in 2007?
Provide a short and direct response. 0.95. What is the ratio of the Female students (as % of total students) of Tajikistan in 2005 to that in 2008?
Your answer should be compact. 0.98. What is the ratio of the Female students (as % of total students) in Zambia in 2005 to that in 2008?
Offer a terse response. 0.98. What is the ratio of the Female students (as % of total students) of France in 2007 to that in 2008?
Your response must be concise. 1. What is the ratio of the Female students (as % of total students) in Uruguay in 2007 to that in 2008?
Your response must be concise. 0.93. What is the ratio of the Female students (as % of total students) in Zambia in 2007 to that in 2008?
Your answer should be very brief. 1.03. What is the difference between the highest and the second highest Female students (as % of total students) in France?
Your answer should be compact. 0.04. What is the difference between the highest and the second highest Female students (as % of total students) in Tajikistan?
Your response must be concise. 0.13. What is the difference between the highest and the second highest Female students (as % of total students) of Uruguay?
Give a very brief answer. 0.25. What is the difference between the highest and the second highest Female students (as % of total students) in Zambia?
Offer a terse response. 1.52. What is the difference between the highest and the lowest Female students (as % of total students) of France?
Your answer should be very brief. 0.35. What is the difference between the highest and the lowest Female students (as % of total students) of Tajikistan?
Your answer should be compact. 1.16. What is the difference between the highest and the lowest Female students (as % of total students) in Uruguay?
Your answer should be compact. 4.94. What is the difference between the highest and the lowest Female students (as % of total students) of Zambia?
Offer a very short reply. 3.44. 